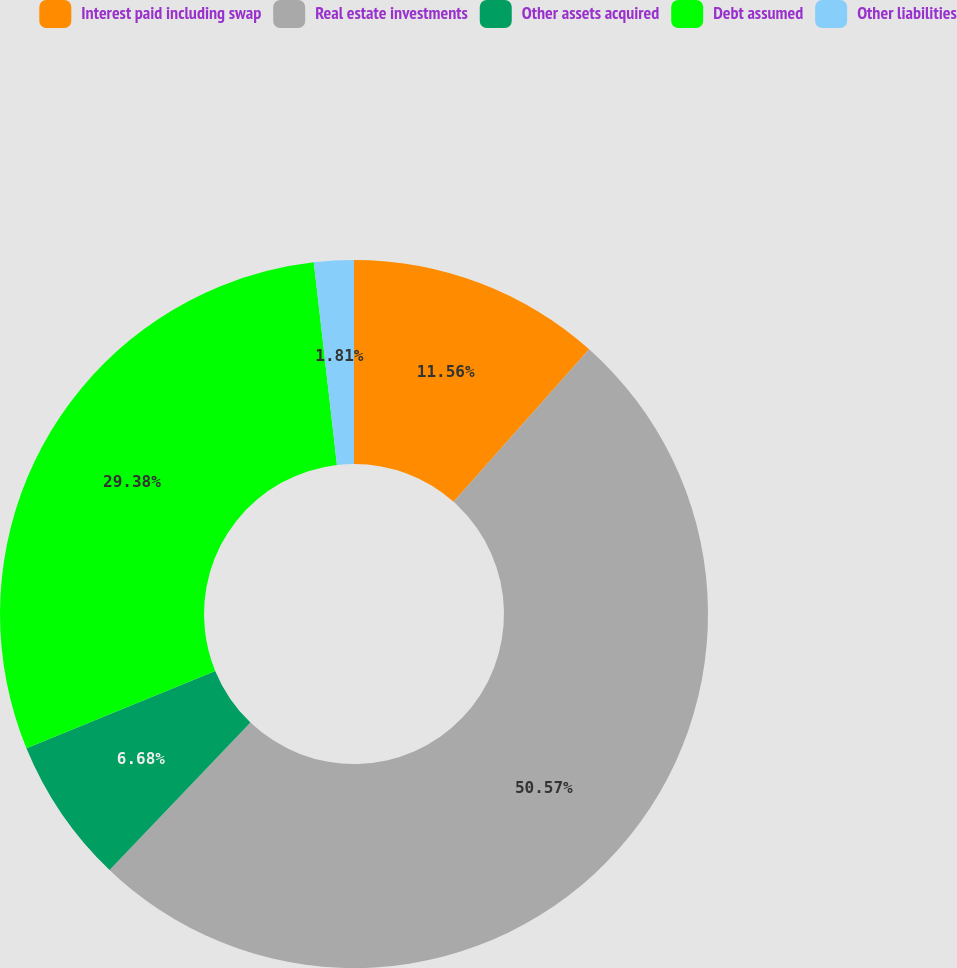Convert chart. <chart><loc_0><loc_0><loc_500><loc_500><pie_chart><fcel>Interest paid including swap<fcel>Real estate investments<fcel>Other assets acquired<fcel>Debt assumed<fcel>Other liabilities<nl><fcel>11.56%<fcel>50.57%<fcel>6.68%<fcel>29.38%<fcel>1.81%<nl></chart> 